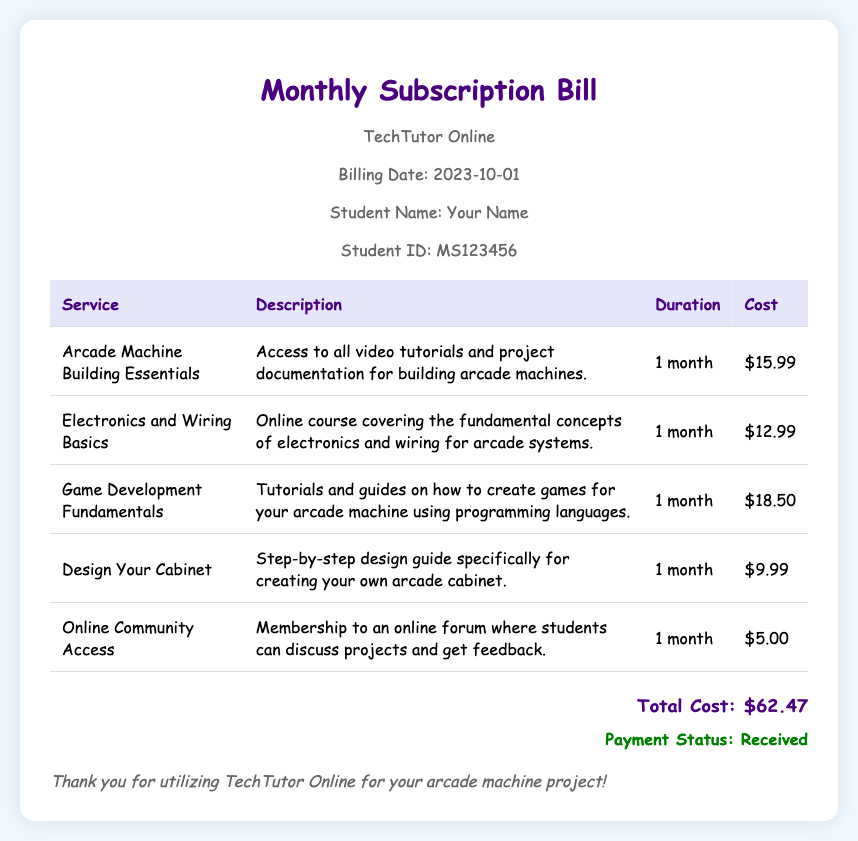what is the billing date? The billing date is listed in the document under the student information section.
Answer: 2023-10-01 who is the student? The student's name is provided in the header section of the document.
Answer: Your Name what is the total cost? The total cost is stated at the bottom of the bill.
Answer: $62.47 how many services are listed? The number of services can be counted from the table in the document, which lists each service.
Answer: 5 what is the cost of the Game Development Fundamentals service? The cost for Game Development Fundamentals is provided in the table.
Answer: $18.50 what type of document is this? The document describes its purpose in the title section and overall content.
Answer: Monthly Subscription Bill which service has the lowest cost? The cost for each service can be compared based on the values in the table.
Answer: Online Community Access what does the payment status indicate? The payment status is shown at the bottom of the document, confirming the payment outcome.
Answer: Received 